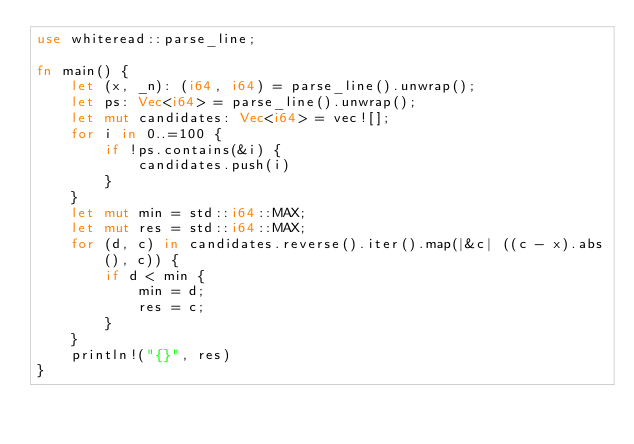<code> <loc_0><loc_0><loc_500><loc_500><_Rust_>use whiteread::parse_line;

fn main() {
    let (x, _n): (i64, i64) = parse_line().unwrap();
    let ps: Vec<i64> = parse_line().unwrap();
    let mut candidates: Vec<i64> = vec![];
    for i in 0..=100 {
        if !ps.contains(&i) {
            candidates.push(i)
        }
    }
    let mut min = std::i64::MAX;
    let mut res = std::i64::MAX;
    for (d, c) in candidates.reverse().iter().map(|&c| ((c - x).abs(), c)) {
        if d < min {
            min = d;
            res = c;
        }
    }
    println!("{}", res)
}
</code> 